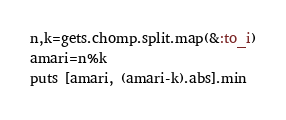<code> <loc_0><loc_0><loc_500><loc_500><_Ruby_>n,k=gets.chomp.split.map(&:to_i)
amari=n%k
puts [amari, (amari-k).abs].min</code> 